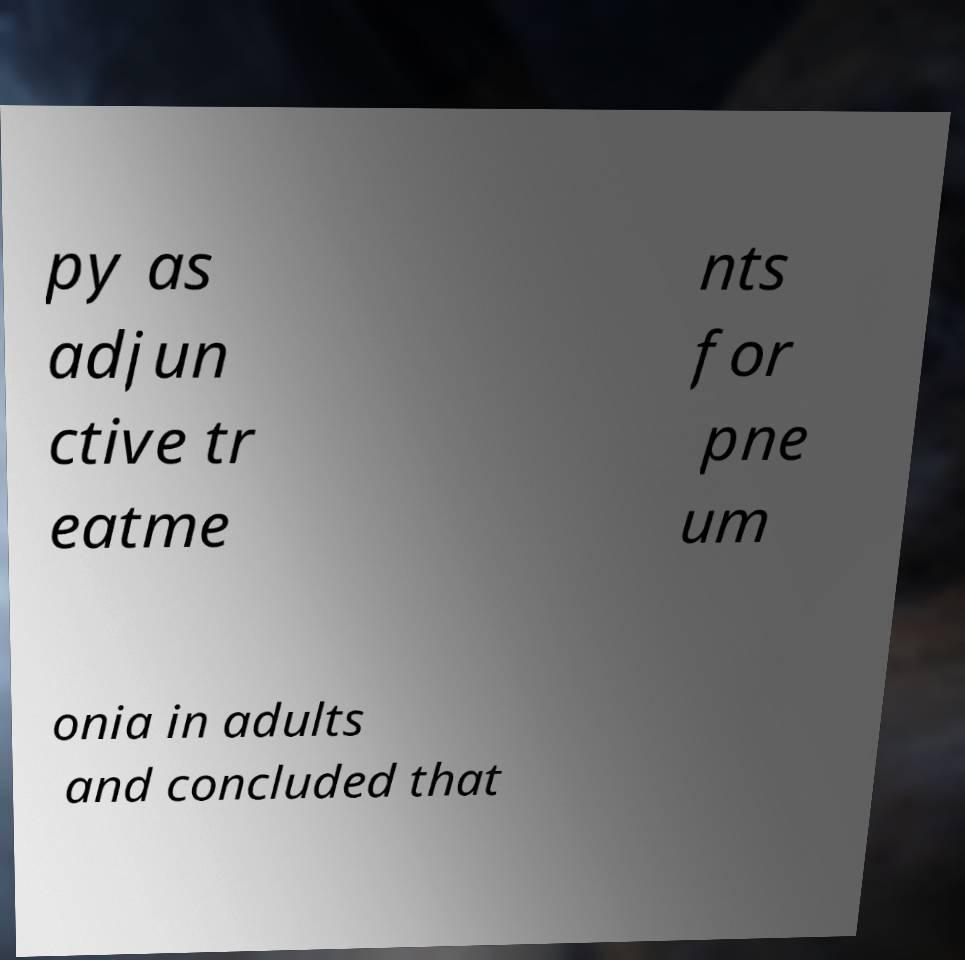Can you read and provide the text displayed in the image?This photo seems to have some interesting text. Can you extract and type it out for me? py as adjun ctive tr eatme nts for pne um onia in adults and concluded that 